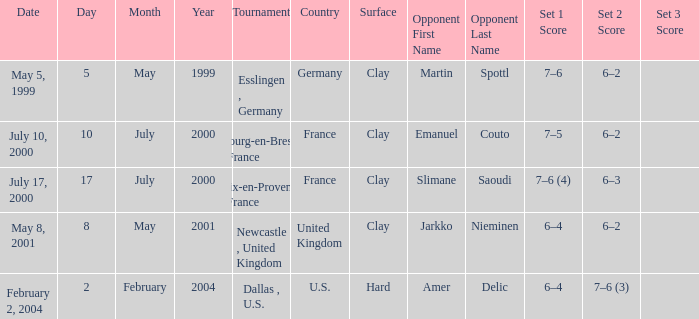What is the Score of the Tournament played on Clay Surface on May 5, 1999? 7–6, 6–2. 